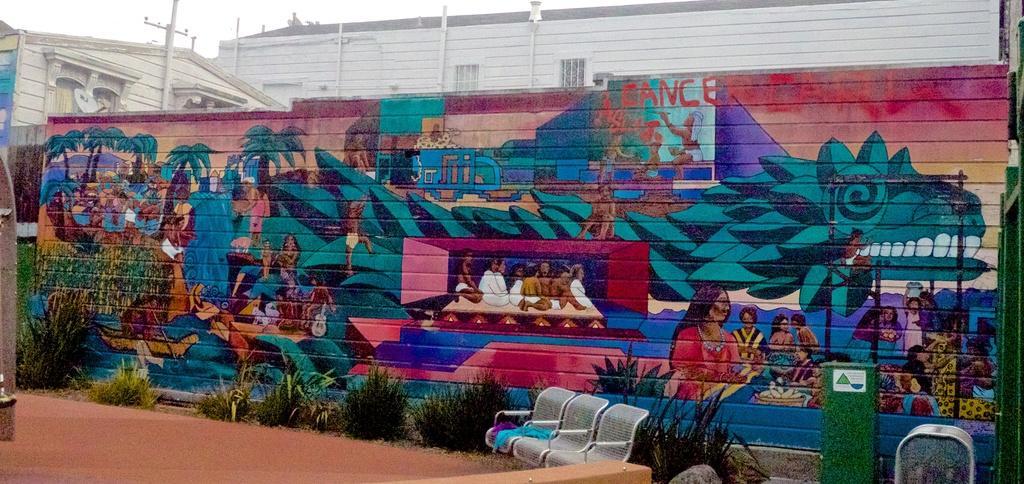Could you give a brief overview of what you see in this image? In this image we can see the buildings, there are plants, chairs, poles and some other objects, also we can see some graffiti on the wall and in the background, we can see the sky. 